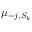<formula> <loc_0><loc_0><loc_500><loc_500>\mu _ { - j , S _ { k } }</formula> 